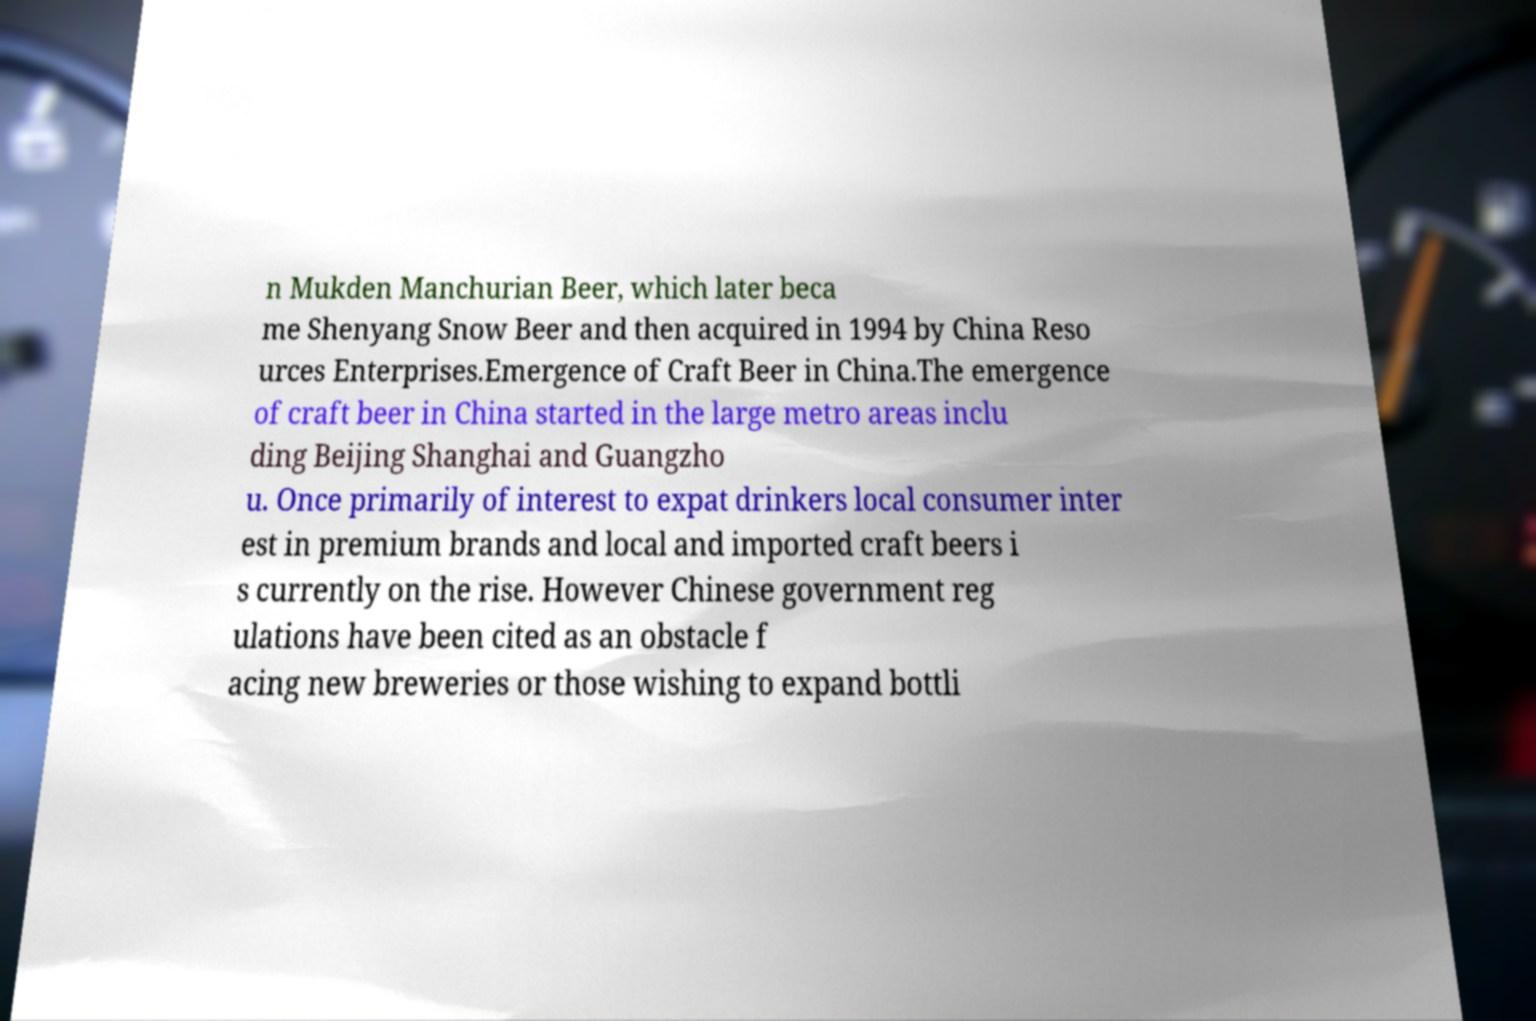For documentation purposes, I need the text within this image transcribed. Could you provide that? n Mukden Manchurian Beer, which later beca me Shenyang Snow Beer and then acquired in 1994 by China Reso urces Enterprises.Emergence of Craft Beer in China.The emergence of craft beer in China started in the large metro areas inclu ding Beijing Shanghai and Guangzho u. Once primarily of interest to expat drinkers local consumer inter est in premium brands and local and imported craft beers i s currently on the rise. However Chinese government reg ulations have been cited as an obstacle f acing new breweries or those wishing to expand bottli 